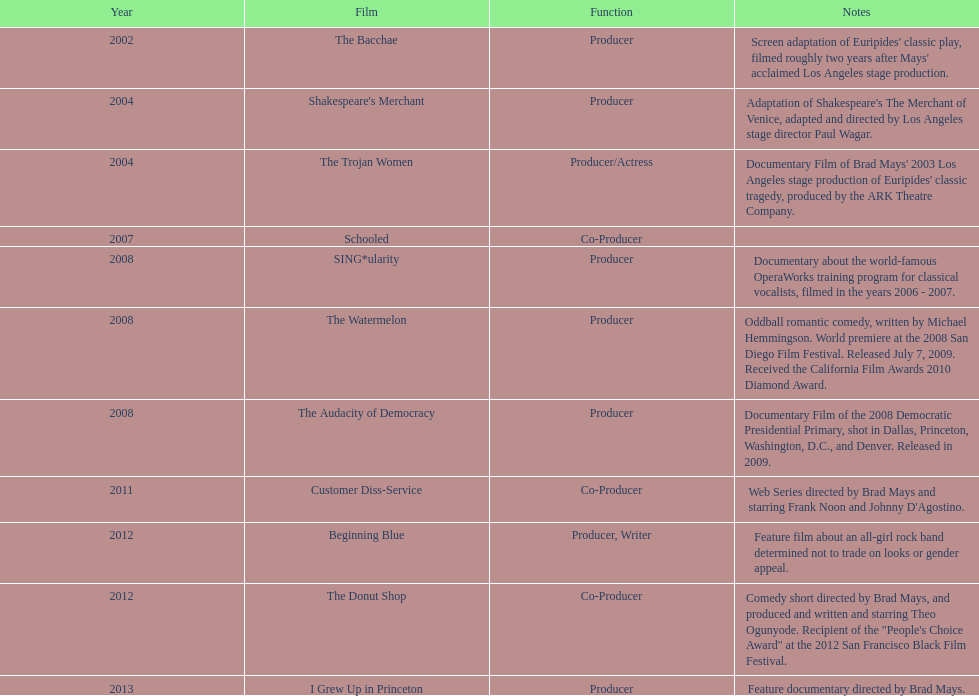Which film was before the audacity of democracy? The Watermelon. 